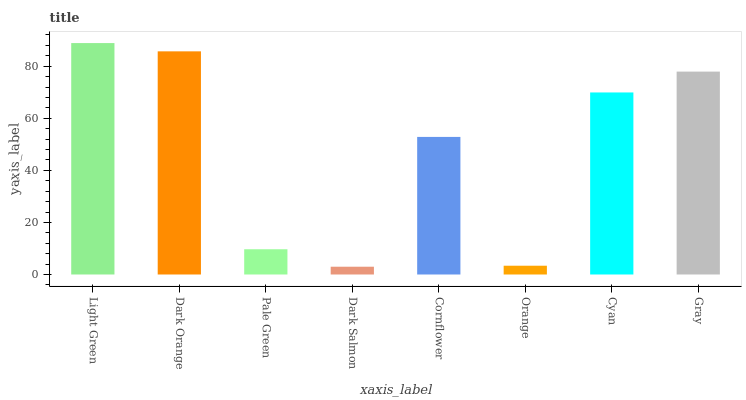Is Dark Orange the minimum?
Answer yes or no. No. Is Dark Orange the maximum?
Answer yes or no. No. Is Light Green greater than Dark Orange?
Answer yes or no. Yes. Is Dark Orange less than Light Green?
Answer yes or no. Yes. Is Dark Orange greater than Light Green?
Answer yes or no. No. Is Light Green less than Dark Orange?
Answer yes or no. No. Is Cyan the high median?
Answer yes or no. Yes. Is Cornflower the low median?
Answer yes or no. Yes. Is Light Green the high median?
Answer yes or no. No. Is Dark Salmon the low median?
Answer yes or no. No. 